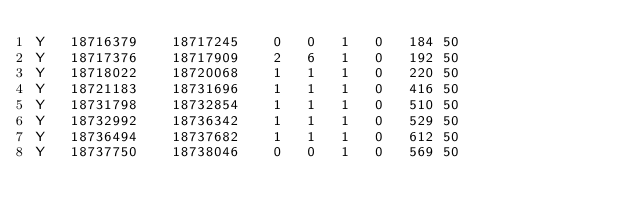Convert code to text. <code><loc_0><loc_0><loc_500><loc_500><_SQL_>Y	18716379	18717245	0	0	1	0	184	50
Y	18717376	18717909	2	6	1	0	192	50
Y	18718022	18720068	1	1	1	0	220	50
Y	18721183	18731696	1	1	1	0	416	50
Y	18731798	18732854	1	1	1	0	510	50
Y	18732992	18736342	1	1	1	0	529	50
Y	18736494	18737682	1	1	1	0	612	50
Y	18737750	18738046	0	0	1	0	569	50
</code> 